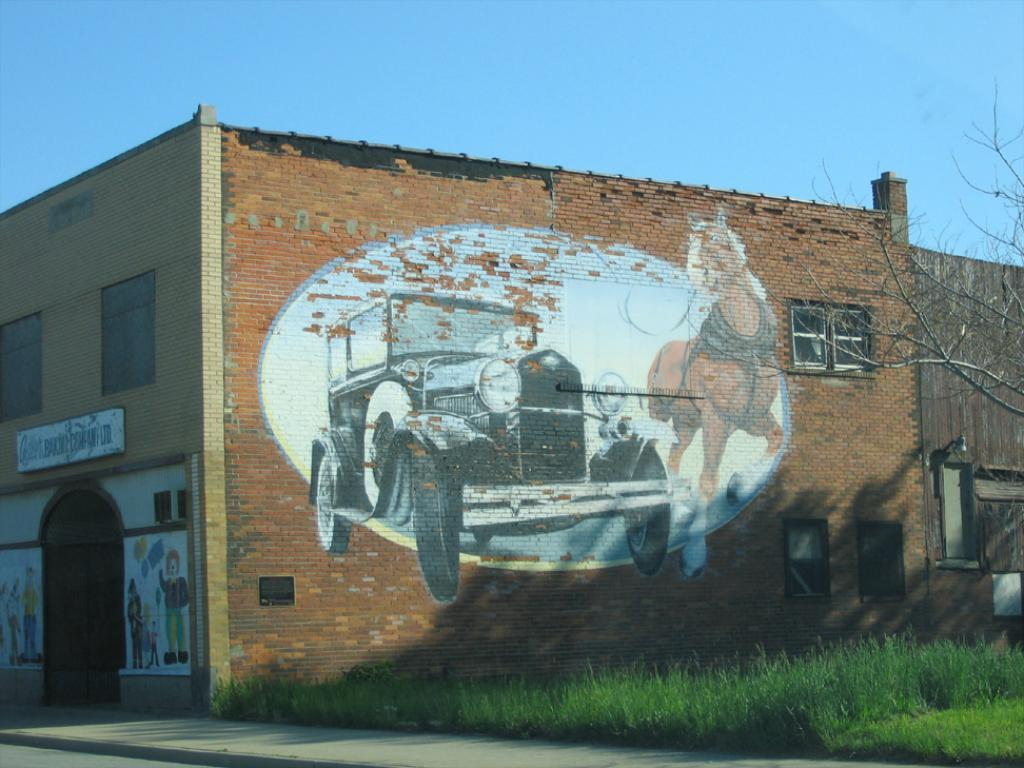What type of structure is visible in the image? There is a building in the image. What can be seen on the building? The building has a picture on it. What is the color of the ground beside the building? The ground beside the building is green. What color is the sky in the image? The sky is blue in color. What type of stick can be seen in the image? There is no stick present in the image. What color is the beef in the image? There is no beef present in the image. 